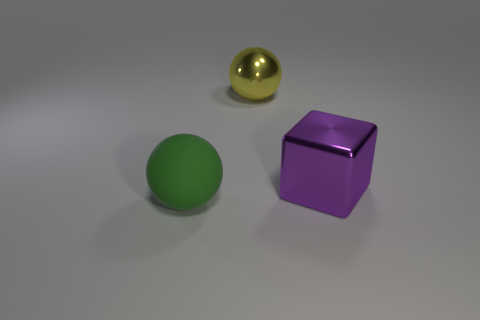Is there anything else that is the same material as the large green thing?
Keep it short and to the point. No. What is the color of the other object that is the same shape as the rubber object?
Offer a very short reply. Yellow. Are there any other things that have the same shape as the large purple shiny thing?
Your response must be concise. No. The yellow metal thing that is the same shape as the big green rubber thing is what size?
Offer a very short reply. Large. How many yellow things are the same material as the big block?
Offer a very short reply. 1. There is a object on the left side of the large sphere that is behind the large green ball; is there a object that is to the right of it?
Make the answer very short. Yes. The yellow shiny thing is what shape?
Offer a very short reply. Sphere. Is the material of the ball behind the metal cube the same as the object that is to the right of the large metallic sphere?
Provide a short and direct response. Yes. What shape is the object that is on the right side of the rubber object and to the left of the big purple metallic object?
Make the answer very short. Sphere. There is a large object that is both in front of the big yellow thing and to the right of the large green matte object; what color is it?
Offer a very short reply. Purple. 